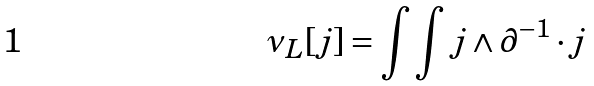Convert formula to latex. <formula><loc_0><loc_0><loc_500><loc_500>\nu _ { L } [ j ] = \int \int j \wedge \partial ^ { - 1 } \cdot j</formula> 